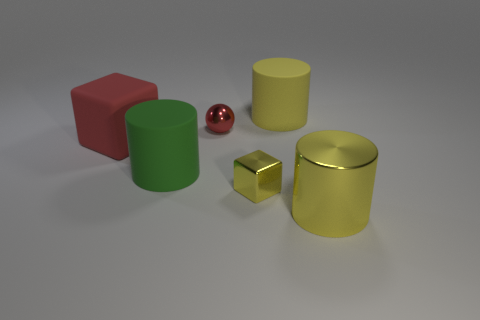How many matte objects are either big red cubes or yellow cubes?
Provide a short and direct response. 1. There is a ball that is the same color as the matte block; what is it made of?
Make the answer very short. Metal. Is the number of tiny yellow blocks that are behind the small yellow metallic cube less than the number of large matte cubes that are behind the metallic sphere?
Provide a succinct answer. No. What number of objects are either big cylinders or red things that are to the right of the green rubber cylinder?
Your answer should be compact. 4. There is a yellow thing that is the same size as the sphere; what is it made of?
Offer a terse response. Metal. Are the tiny yellow block and the large green cylinder made of the same material?
Offer a very short reply. No. What is the color of the thing that is both in front of the green matte thing and to the left of the yellow metal cylinder?
Your answer should be very brief. Yellow. There is a small sphere that is to the left of the metal cylinder; does it have the same color as the metallic block?
Provide a succinct answer. No. What is the shape of the red rubber thing that is the same size as the green thing?
Provide a short and direct response. Cube. What number of other things are the same color as the shiny cube?
Provide a succinct answer. 2. 